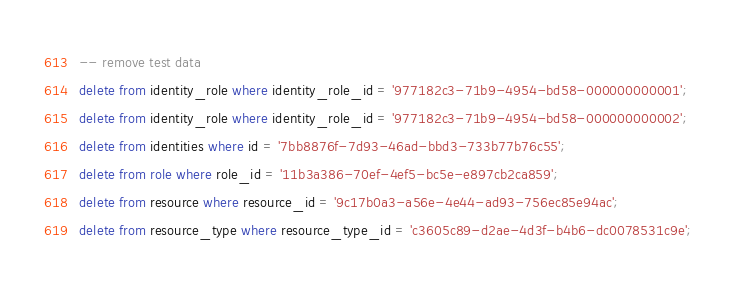Convert code to text. <code><loc_0><loc_0><loc_500><loc_500><_SQL_>-- remove test data
delete from identity_role where identity_role_id = '977182c3-71b9-4954-bd58-000000000001';
delete from identity_role where identity_role_id = '977182c3-71b9-4954-bd58-000000000002';
delete from identities where id = '7bb8876f-7d93-46ad-bbd3-733b77b76c55';
delete from role where role_id = '11b3a386-70ef-4ef5-bc5e-e897cb2ca859';
delete from resource where resource_id = '9c17b0a3-a56e-4e44-ad93-756ec85e94ac';
delete from resource_type where resource_type_id = 'c3605c89-d2ae-4d3f-b4b6-dc0078531c9e';</code> 